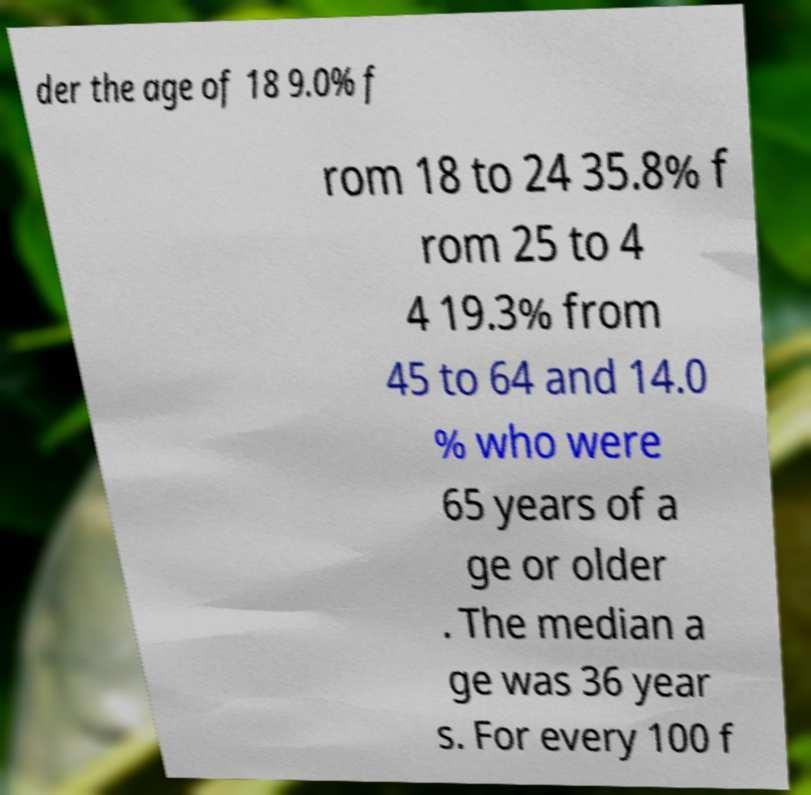Could you extract and type out the text from this image? der the age of 18 9.0% f rom 18 to 24 35.8% f rom 25 to 4 4 19.3% from 45 to 64 and 14.0 % who were 65 years of a ge or older . The median a ge was 36 year s. For every 100 f 